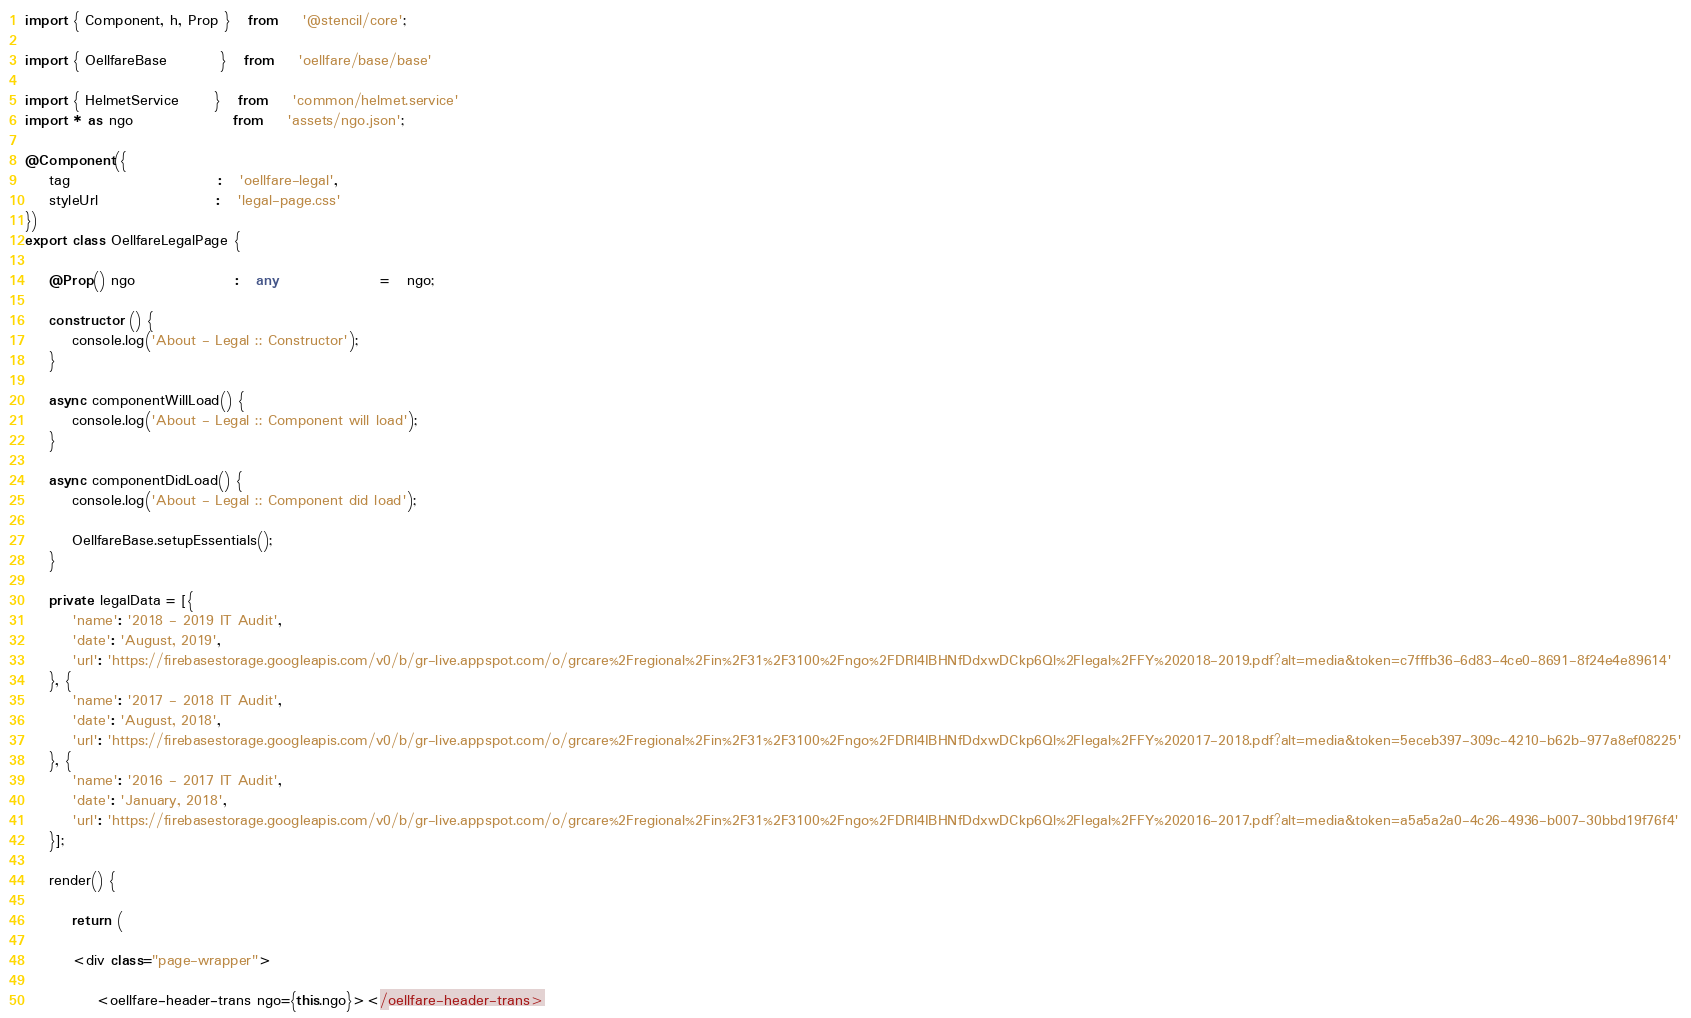Convert code to text. <code><loc_0><loc_0><loc_500><loc_500><_TypeScript_>import { Component, h, Prop }   from    '@stencil/core';

import { OellfareBase         }   from    'oellfare/base/base'

import { HelmetService      }   from    'common/helmet.service'
import * as ngo                 from    'assets/ngo.json';

@Component({
    tag                         :   'oellfare-legal',
    styleUrl                    :   'legal-page.css'
})
export class OellfareLegalPage {

    @Prop() ngo                 :   any                 =   ngo;

    constructor () {
        console.log('About - Legal :: Constructor');
    }

    async componentWillLoad() {
        console.log('About - Legal :: Component will load');
    }

    async componentDidLoad() {
        console.log('About - Legal :: Component did load');

        OellfareBase.setupEssentials();
    }

    private legalData = [{
        'name': '2018 - 2019 IT Audit',
        'date': 'August, 2019',
        'url': 'https://firebasestorage.googleapis.com/v0/b/gr-live.appspot.com/o/grcare%2Fregional%2Fin%2F31%2F3100%2Fngo%2FDRl4IBHNfDdxwDCkp6Ql%2Flegal%2FFY%202018-2019.pdf?alt=media&token=c7fffb36-6d83-4ce0-8691-8f24e4e89614'
    }, {
        'name': '2017 - 2018 IT Audit',
        'date': 'August, 2018',
        'url': 'https://firebasestorage.googleapis.com/v0/b/gr-live.appspot.com/o/grcare%2Fregional%2Fin%2F31%2F3100%2Fngo%2FDRl4IBHNfDdxwDCkp6Ql%2Flegal%2FFY%202017-2018.pdf?alt=media&token=5eceb397-309c-4210-b62b-977a8ef08225'
    }, {
        'name': '2016 - 2017 IT Audit',
        'date': 'January, 2018',
        'url': 'https://firebasestorage.googleapis.com/v0/b/gr-live.appspot.com/o/grcare%2Fregional%2Fin%2F31%2F3100%2Fngo%2FDRl4IBHNfDdxwDCkp6Ql%2Flegal%2FFY%202016-2017.pdf?alt=media&token=a5a5a2a0-4c26-4936-b007-30bbd19f76f4'
    }];

    render() {

        return (

        <div class="page-wrapper">

            <oellfare-header-trans ngo={this.ngo}></oellfare-header-trans>
</code> 